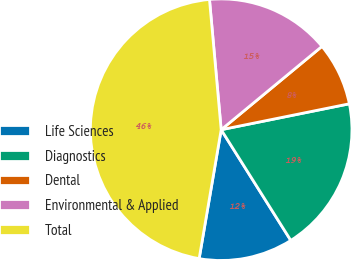<chart> <loc_0><loc_0><loc_500><loc_500><pie_chart><fcel>Life Sciences<fcel>Diagnostics<fcel>Dental<fcel>Environmental & Applied<fcel>Total<nl><fcel>11.63%<fcel>19.24%<fcel>7.82%<fcel>15.43%<fcel>45.88%<nl></chart> 